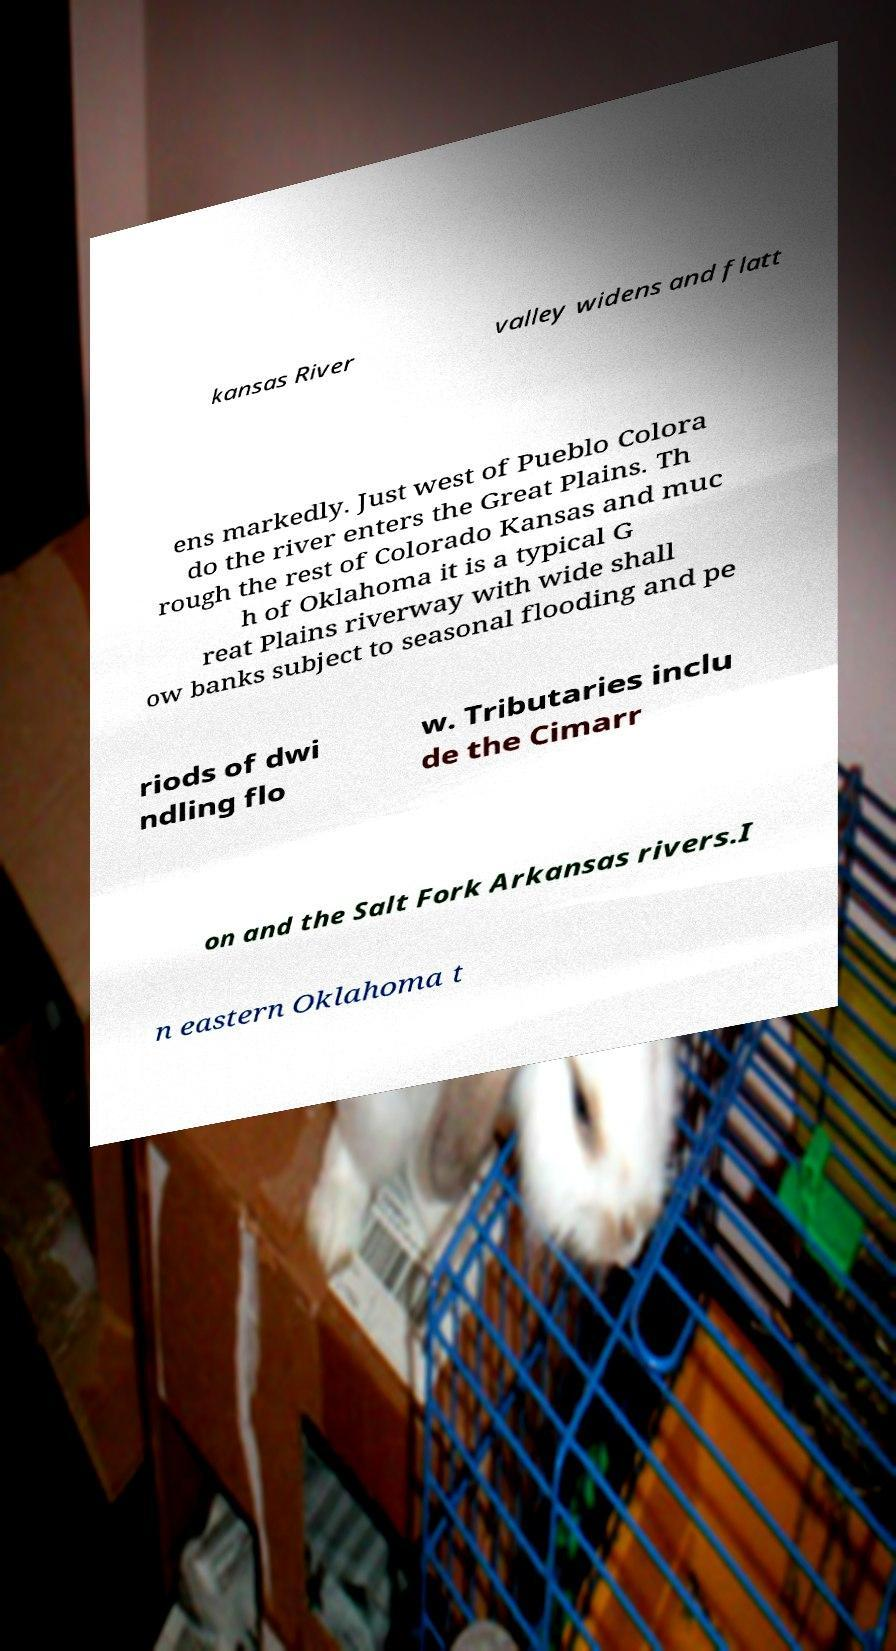What messages or text are displayed in this image? I need them in a readable, typed format. kansas River valley widens and flatt ens markedly. Just west of Pueblo Colora do the river enters the Great Plains. Th rough the rest of Colorado Kansas and muc h of Oklahoma it is a typical G reat Plains riverway with wide shall ow banks subject to seasonal flooding and pe riods of dwi ndling flo w. Tributaries inclu de the Cimarr on and the Salt Fork Arkansas rivers.I n eastern Oklahoma t 